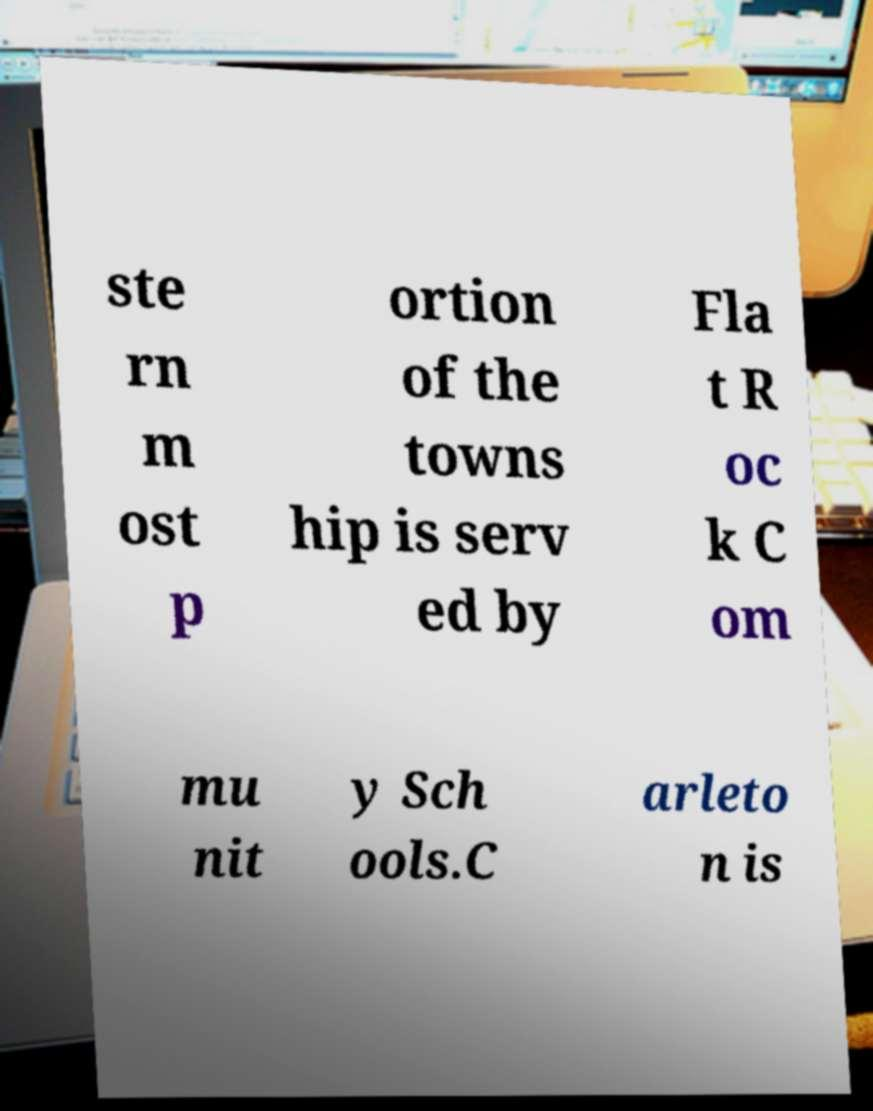Please identify and transcribe the text found in this image. ste rn m ost p ortion of the towns hip is serv ed by Fla t R oc k C om mu nit y Sch ools.C arleto n is 